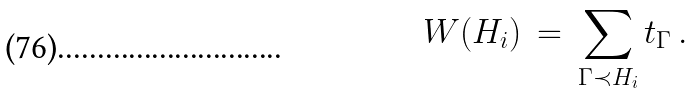Convert formula to latex. <formula><loc_0><loc_0><loc_500><loc_500>W ( H _ { i } ) \, = \, \sum _ { \Gamma \prec H _ { i } } t _ { \Gamma } \, .</formula> 